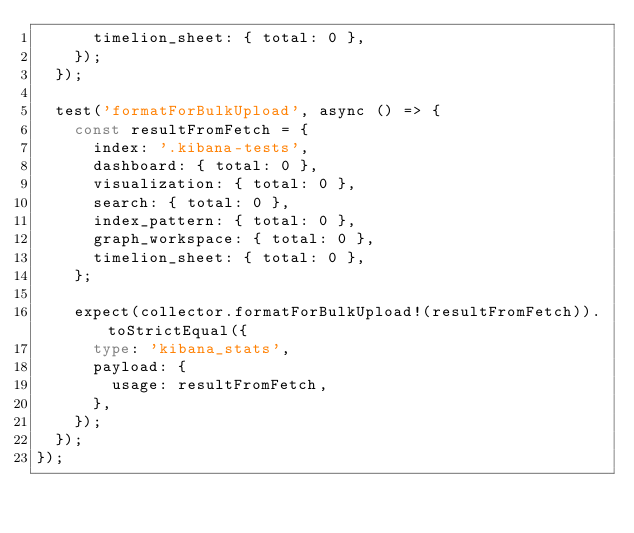<code> <loc_0><loc_0><loc_500><loc_500><_TypeScript_>      timelion_sheet: { total: 0 },
    });
  });

  test('formatForBulkUpload', async () => {
    const resultFromFetch = {
      index: '.kibana-tests',
      dashboard: { total: 0 },
      visualization: { total: 0 },
      search: { total: 0 },
      index_pattern: { total: 0 },
      graph_workspace: { total: 0 },
      timelion_sheet: { total: 0 },
    };

    expect(collector.formatForBulkUpload!(resultFromFetch)).toStrictEqual({
      type: 'kibana_stats',
      payload: {
        usage: resultFromFetch,
      },
    });
  });
});
</code> 